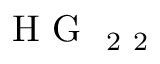<formula> <loc_0><loc_0><loc_500><loc_500>H G _ { 2 2 }</formula> 